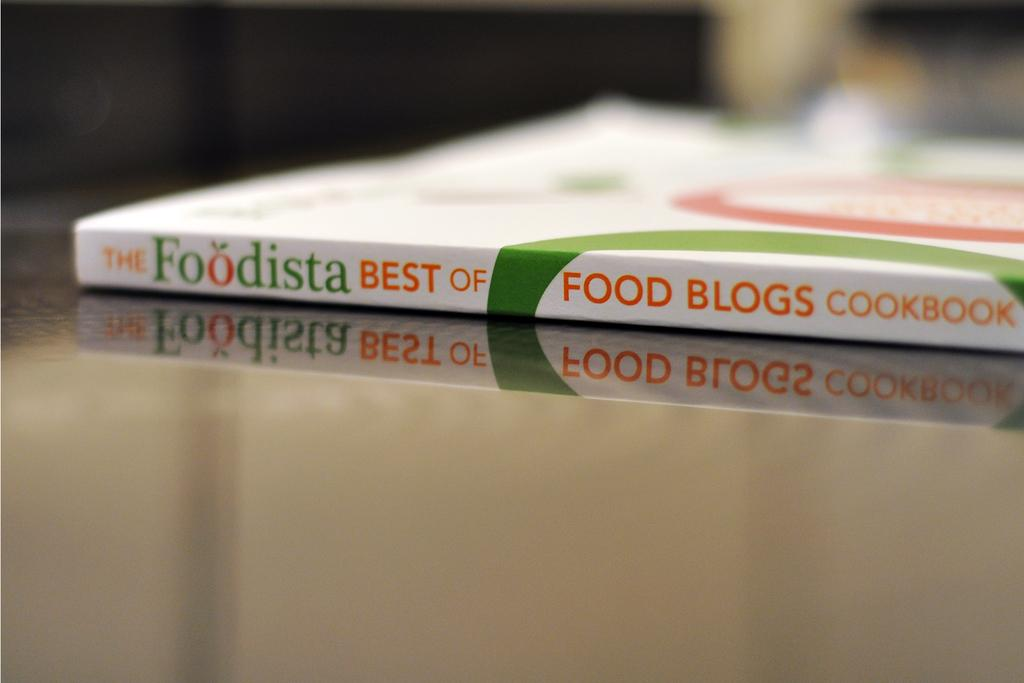<image>
Summarize the visual content of the image. A Best of Food Blogs cookbook sits on a countertop. 